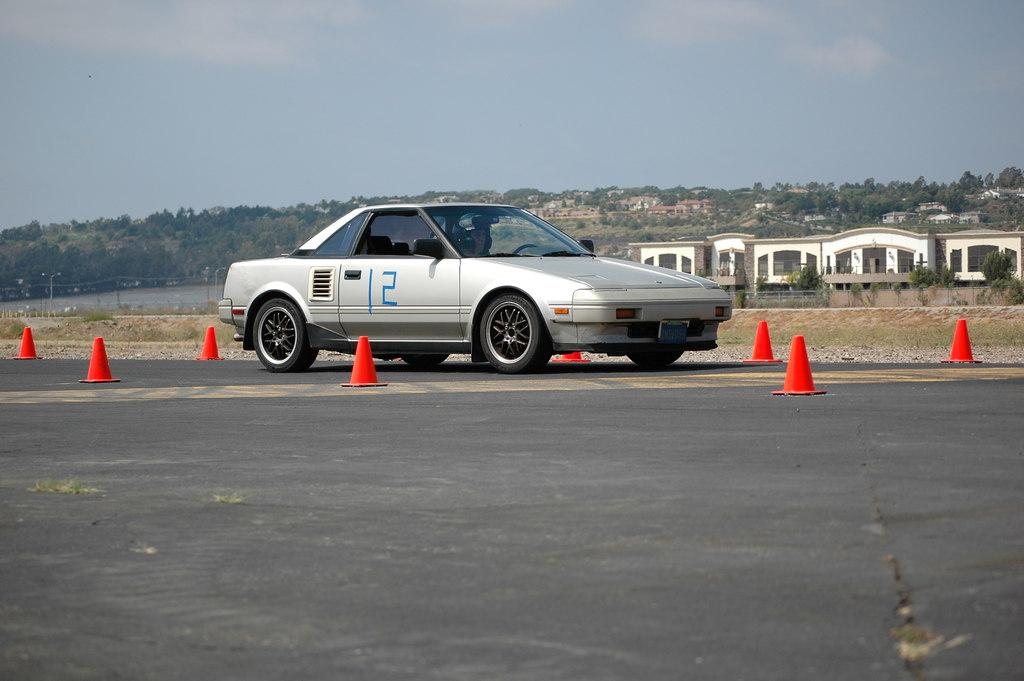What is the person in the image doing? The person in the image is driving a vehicle. Where is the vehicle located? The vehicle is on the road. What can be seen in the background of the image? There are buildings, trees, and the sky with clouds visible in the background of the image. What objects are present on the road? Traffic cones are present on the road. What other structures are visible in the image? Poles and lights are visible in the image. What type of lamp is hanging from the blade in the image? There is no lamp or blade present in the image. 